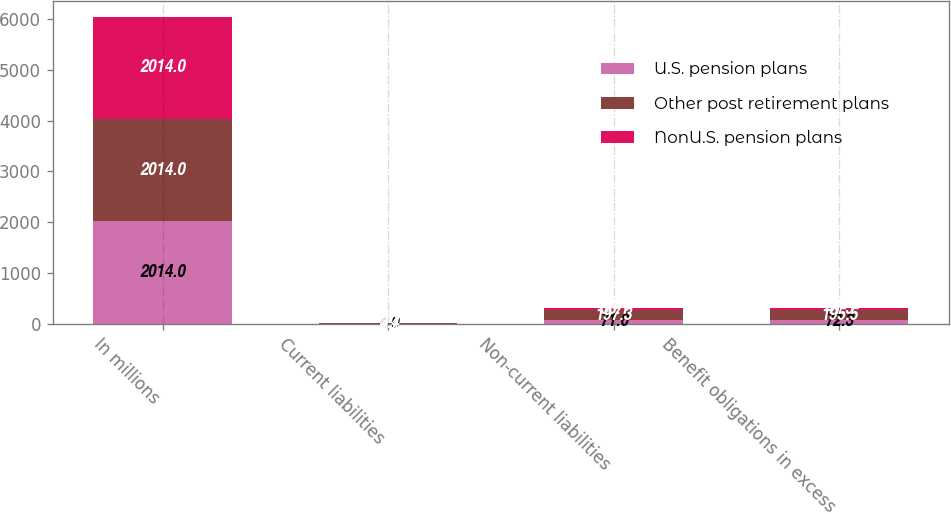Convert chart. <chart><loc_0><loc_0><loc_500><loc_500><stacked_bar_chart><ecel><fcel>In millions<fcel>Current liabilities<fcel>Non-current liabilities<fcel>Benefit obligations in excess<nl><fcel>U.S. pension plans<fcel>2014<fcel>4<fcel>71<fcel>72.3<nl><fcel>Other post retirement plans<fcel>2014<fcel>4.7<fcel>197.3<fcel>195.5<nl><fcel>NonU.S. pension plans<fcel>2014<fcel>3.4<fcel>38.1<fcel>41.5<nl></chart> 